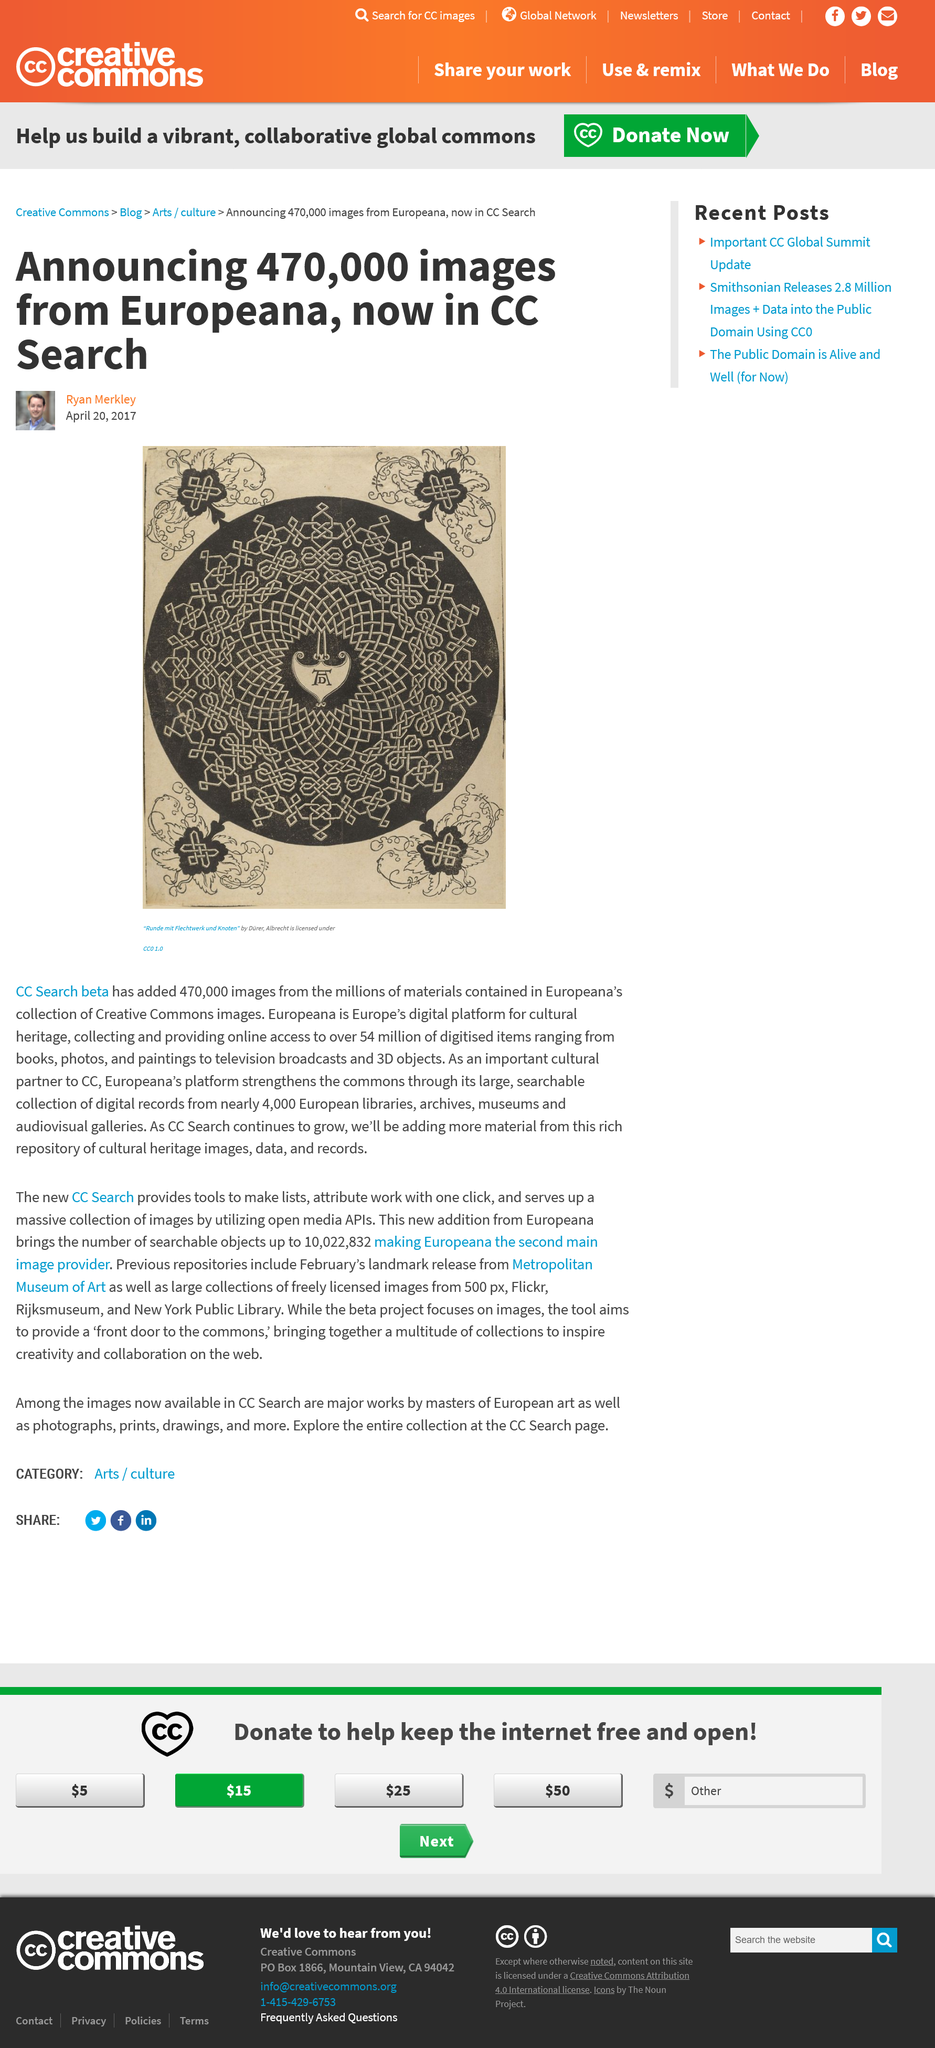Indicate a few pertinent items in this graphic. A total of 470,000 images have been added to CC Search beta. Nearly 4000 European libraries, archives, museums, and galleries have provided digital records. Albrecht Dürer created the work titled "Runde mit Flechtwerk und Knoten". 